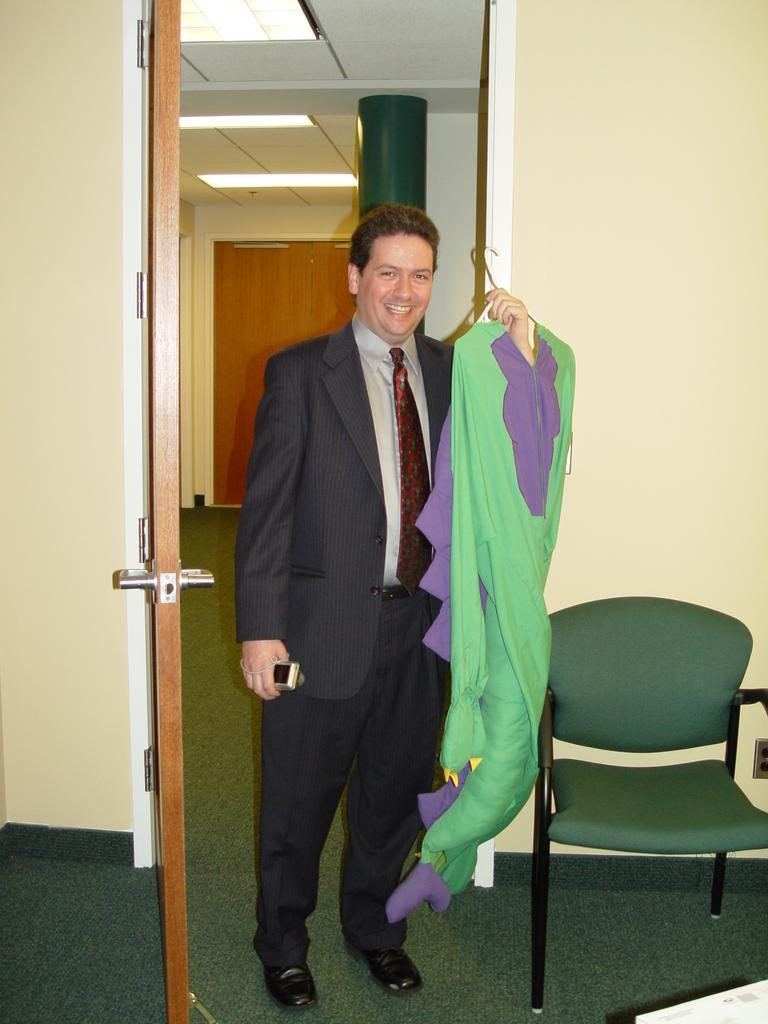Can you describe this image briefly? This image is taken indoors. At the bottom of the image there is a floor. In the background there are a few walls and there are two doors. At the top of the image there is a ceiling with a few lights. On the right side of the image there is an empty chair on the floor. In the middle of the image a man is standing and he is holding a mobile phone and a mermaid costume in his hands. He is with a smiling face. 